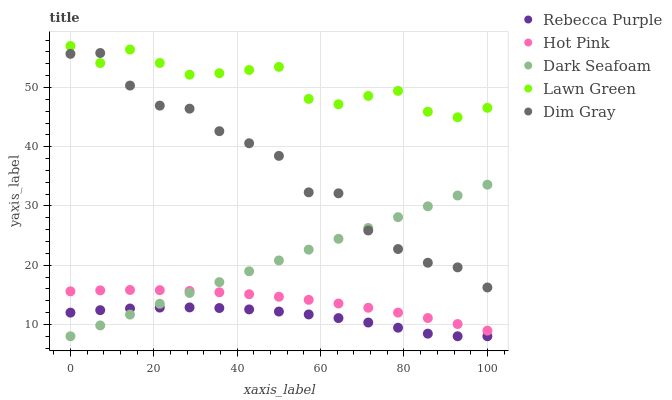Does Rebecca Purple have the minimum area under the curve?
Answer yes or no. Yes. Does Lawn Green have the maximum area under the curve?
Answer yes or no. Yes. Does Dark Seafoam have the minimum area under the curve?
Answer yes or no. No. Does Dark Seafoam have the maximum area under the curve?
Answer yes or no. No. Is Dark Seafoam the smoothest?
Answer yes or no. Yes. Is Dim Gray the roughest?
Answer yes or no. Yes. Is Hot Pink the smoothest?
Answer yes or no. No. Is Hot Pink the roughest?
Answer yes or no. No. Does Dark Seafoam have the lowest value?
Answer yes or no. Yes. Does Hot Pink have the lowest value?
Answer yes or no. No. Does Lawn Green have the highest value?
Answer yes or no. Yes. Does Dark Seafoam have the highest value?
Answer yes or no. No. Is Rebecca Purple less than Hot Pink?
Answer yes or no. Yes. Is Dim Gray greater than Hot Pink?
Answer yes or no. Yes. Does Dark Seafoam intersect Hot Pink?
Answer yes or no. Yes. Is Dark Seafoam less than Hot Pink?
Answer yes or no. No. Is Dark Seafoam greater than Hot Pink?
Answer yes or no. No. Does Rebecca Purple intersect Hot Pink?
Answer yes or no. No. 